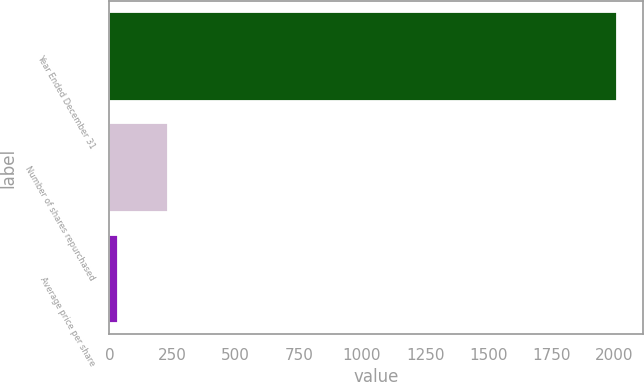Convert chart to OTSL. <chart><loc_0><loc_0><loc_500><loc_500><bar_chart><fcel>Year Ended December 31<fcel>Number of shares repurchased<fcel>Average price per share<nl><fcel>2011<fcel>231.46<fcel>33.73<nl></chart> 